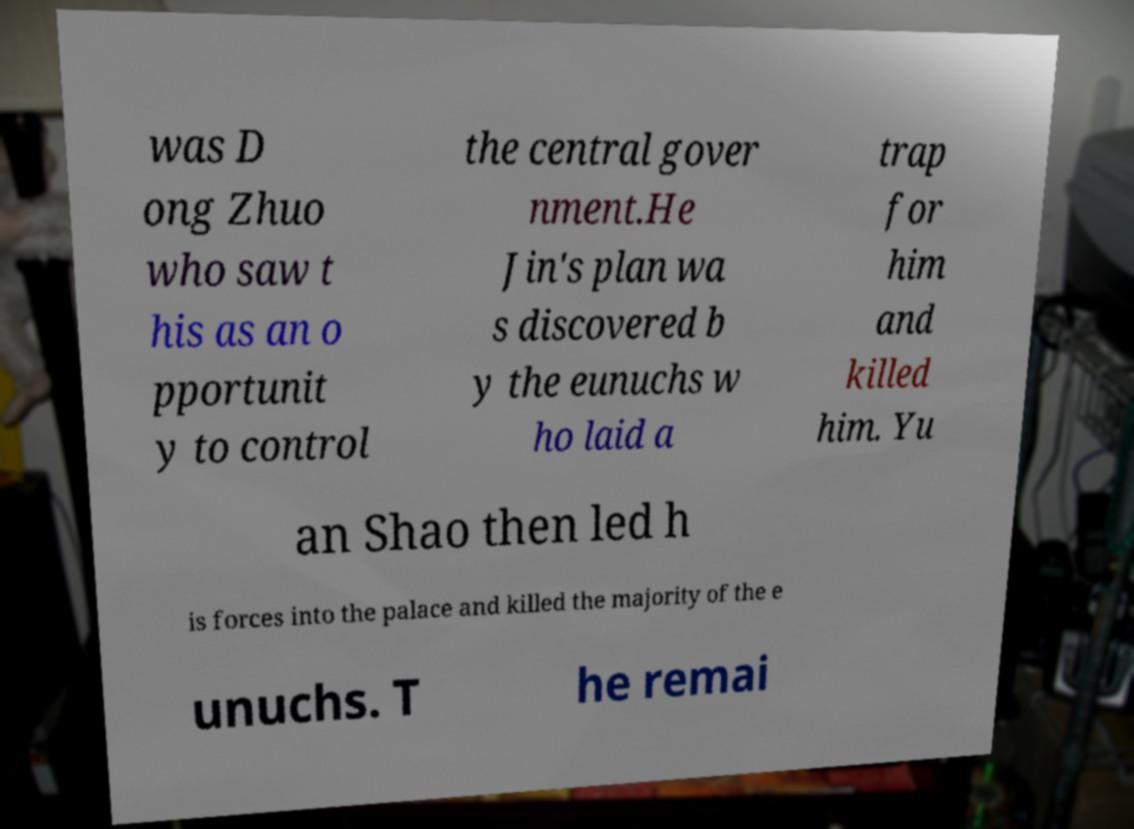Can you read and provide the text displayed in the image?This photo seems to have some interesting text. Can you extract and type it out for me? was D ong Zhuo who saw t his as an o pportunit y to control the central gover nment.He Jin's plan wa s discovered b y the eunuchs w ho laid a trap for him and killed him. Yu an Shao then led h is forces into the palace and killed the majority of the e unuchs. T he remai 